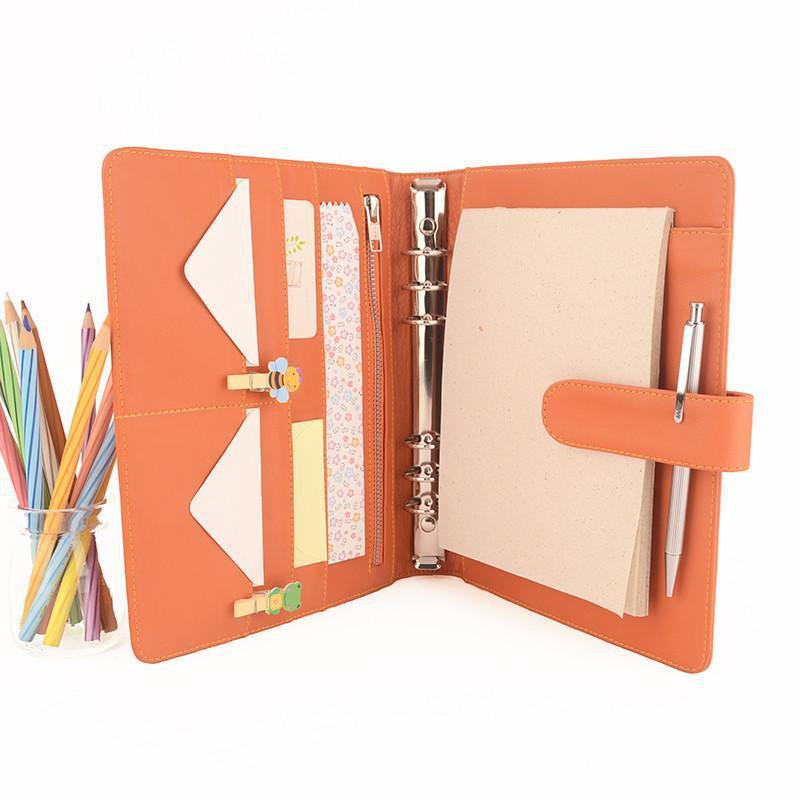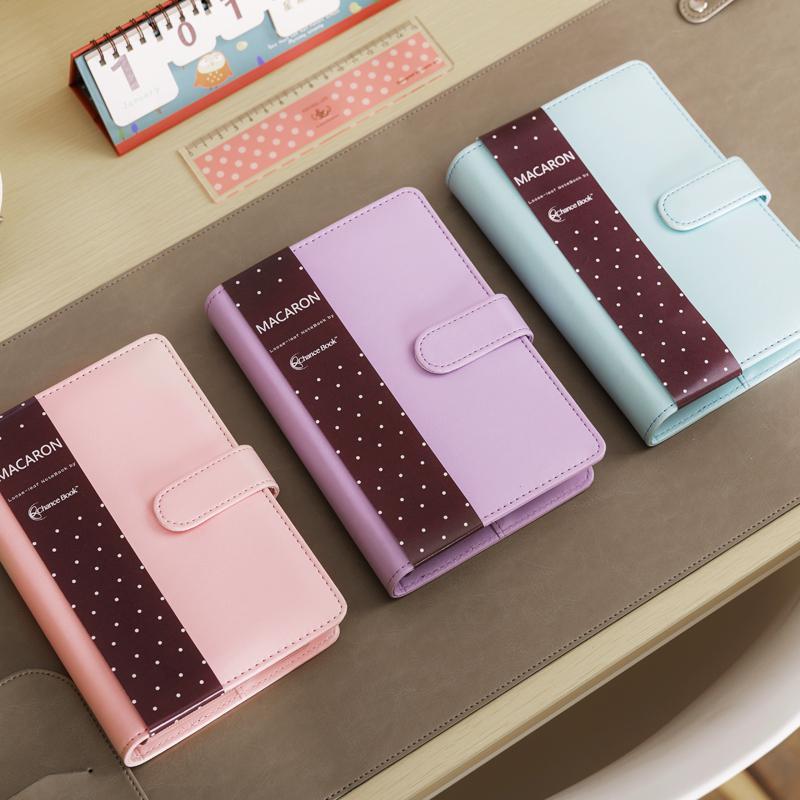The first image is the image on the left, the second image is the image on the right. Examine the images to the left and right. Is the description "In one image, a peach colored notebook is shown in an open position, displaying its contents." accurate? Answer yes or no. Yes. The first image is the image on the left, the second image is the image on the right. Considering the images on both sides, is "One image shows exactly one open orange binder." valid? Answer yes or no. Yes. 